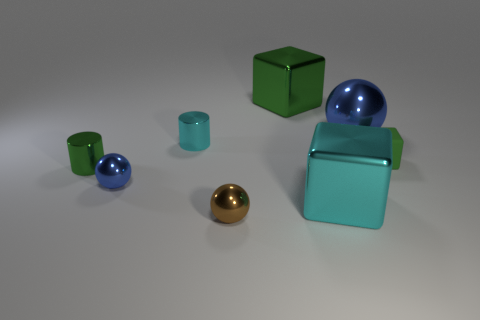Subtract 1 blocks. How many blocks are left? 2 Add 1 large cyan rubber balls. How many objects exist? 9 Subtract 0 red spheres. How many objects are left? 8 Subtract all cubes. How many objects are left? 5 Subtract all large cyan cubes. Subtract all large blue metallic spheres. How many objects are left? 6 Add 5 large blue metal things. How many large blue metal things are left? 6 Add 8 large blue spheres. How many large blue spheres exist? 9 